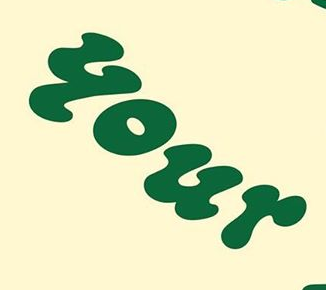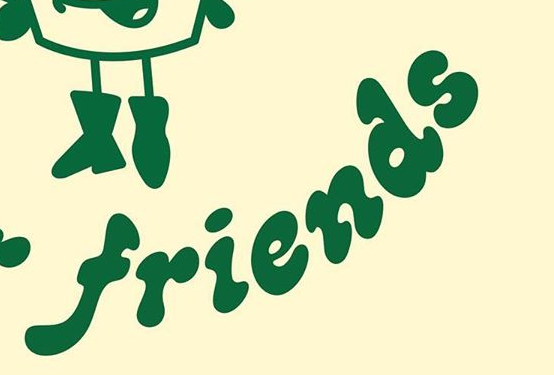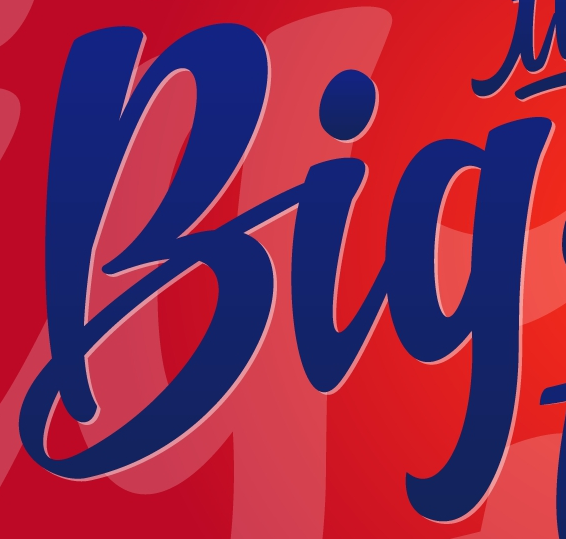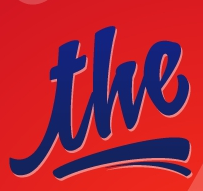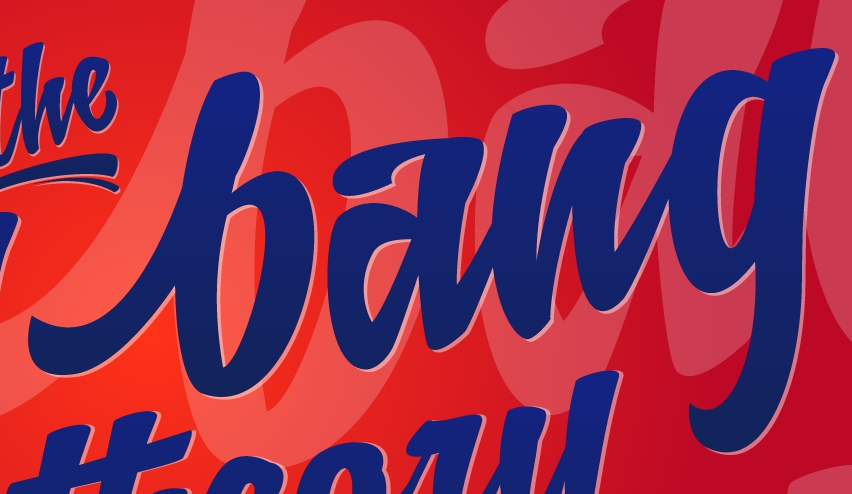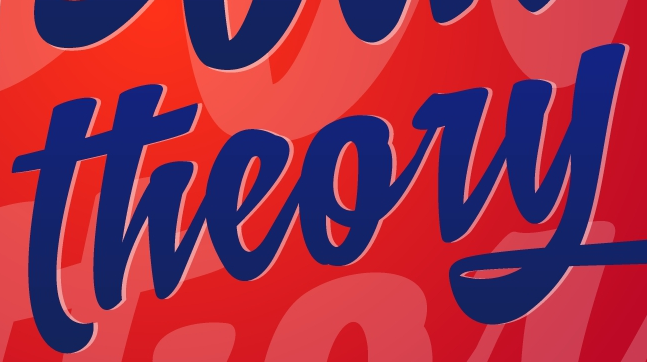What words can you see in these images in sequence, separated by a semicolon? your; friends; Big; the; bang; theory 